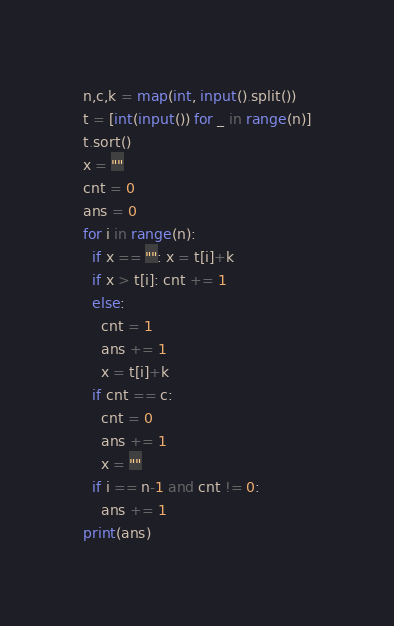<code> <loc_0><loc_0><loc_500><loc_500><_Python_>n,c,k = map(int, input().split())
t = [int(input()) for _ in range(n)]
t.sort()
x = ""
cnt = 0
ans = 0
for i in range(n):
  if x == "": x = t[i]+k
  if x > t[i]: cnt += 1
  else:
    cnt = 1
    ans += 1
    x = t[i]+k
  if cnt == c:
    cnt = 0
    ans += 1
    x = ""
  if i == n-1 and cnt != 0:
    ans += 1
print(ans)</code> 